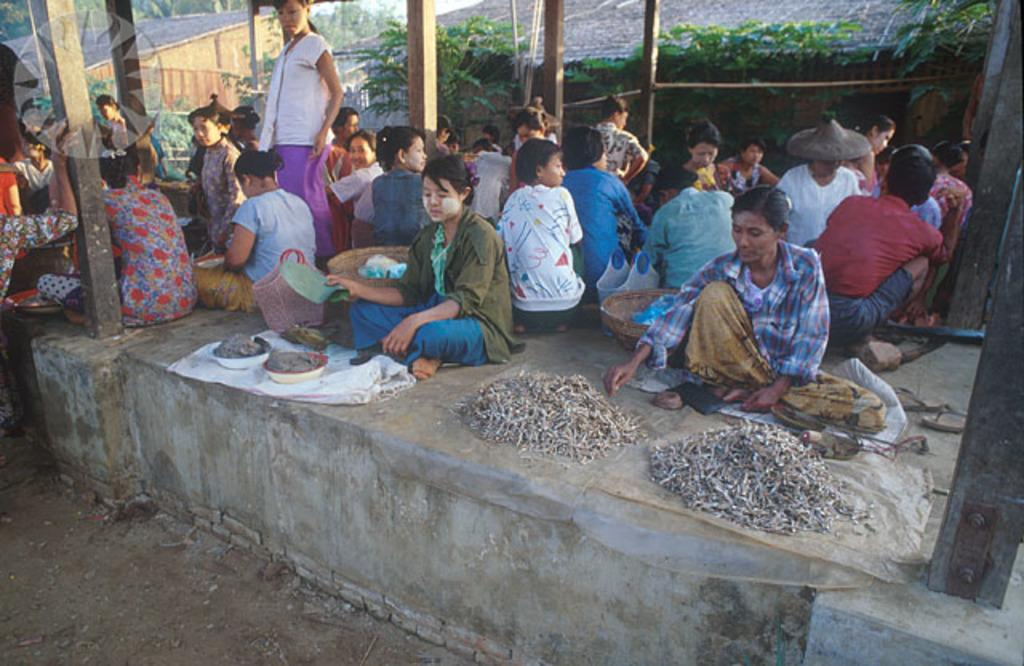What are the people in the image doing? There is a group of people sitting on the floor in the image. What type of containers can be seen in the image? There are baskets and bowls in the image. What can be found near the people's feet? There is footwear in the image. What architectural features are present in the image? There are pillars and a wall in the image. What objects are visible in the image? There are some objects in the image. What can be seen in the background of the image? There are trees and sheds in the background of the image. What type of soda is being served in the image? There is no soda present in the image. What is the texture of the floor in the image? The texture of the floor cannot be determined from the image alone, as it is a two-dimensional representation. 